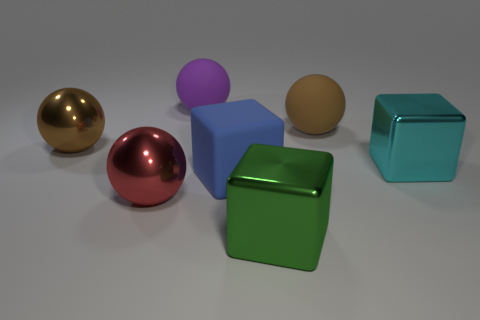Add 1 cyan cubes. How many objects exist? 8 Subtract all balls. How many objects are left? 3 Add 5 red things. How many red things exist? 6 Subtract 2 brown balls. How many objects are left? 5 Subtract all large shiny spheres. Subtract all big balls. How many objects are left? 1 Add 1 large blue blocks. How many large blue blocks are left? 2 